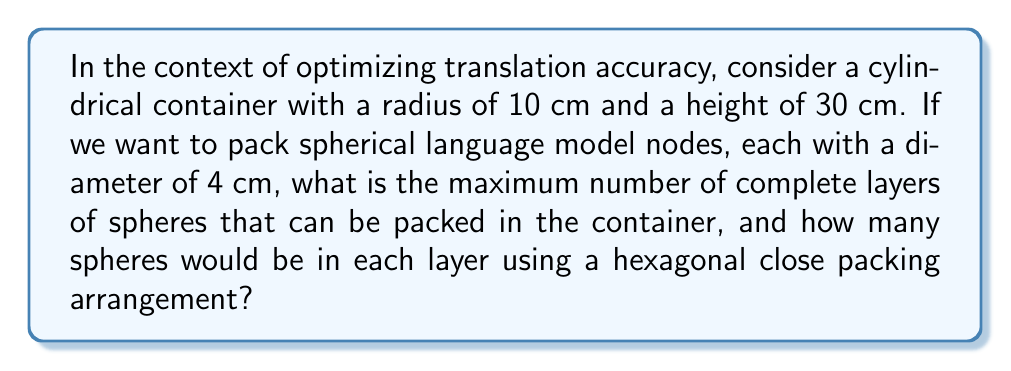Show me your answer to this math problem. Let's approach this step-by-step:

1) In a hexagonal close packing arrangement, spheres are arranged in layers, with each layer forming a hexagonal pattern.

2) The radius of each sphere is 2 cm (half the diameter).

3) In a hexagonal arrangement, the distance between the centers of adjacent spheres in a layer is equal to the sphere diameter. Here, it's 4 cm.

4) The radius of the cylinder is 10 cm. To calculate how many spheres fit across the diameter of the cylinder:

   $$\frac{2 * 10\text{ cm}}{4\text{ cm}} = 5$$

   This means we can fit 5 spheres across the diameter.

5) For a hexagonal arrangement, the number of spheres in a layer can be calculated using the formula:

   $$N = 3n(n-1) + 1$$

   where n is the number of spheres across the radius.

   Here, $n = 3$ (half of 5, rounded up), so:

   $$N = 3 * 3 * (3-1) + 1 = 19$$

6) Now, for the number of layers:

   The height of each layer in a hexagonal close packing is:

   $$h = \sqrt{\frac{2}{3}} * d = \sqrt{\frac{2}{3}} * 4\text{ cm} \approx 3.27\text{ cm}$$

7) The number of complete layers that can fit in the 30 cm height:

   $$\frac{30\text{ cm}}{3.27\text{ cm}} \approx 9.17$$

   We can fit 9 complete layers.
Answer: 9 layers, 19 spheres per layer 